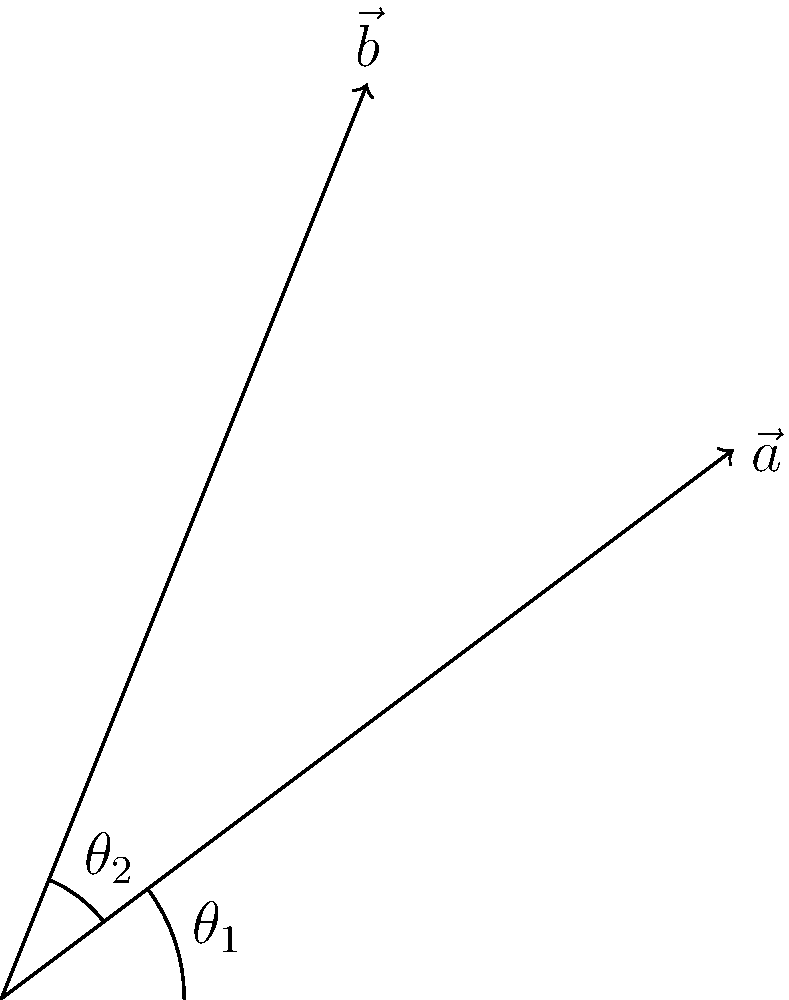Louise Hazel, a renowned heptathlete, is analyzing two shot put throws. The first throw is represented by vector $\vec{a} = 4\hat{i} + 3\hat{j}$, and the second throw by vector $\vec{b} = 2\hat{i} + 5\hat{j}$. What is the angle between these two vectors? To find the angle between two vectors, we can use the dot product formula:

$$\cos \theta = \frac{\vec{a} \cdot \vec{b}}{|\vec{a}||\vec{b}|}$$

Step 1: Calculate the dot product $\vec{a} \cdot \vec{b}$
$\vec{a} \cdot \vec{b} = (4)(2) + (3)(5) = 8 + 15 = 23$

Step 2: Calculate the magnitudes of $\vec{a}$ and $\vec{b}$
$|\vec{a}| = \sqrt{4^2 + 3^2} = \sqrt{16 + 9} = \sqrt{25} = 5$
$|\vec{b}| = \sqrt{2^2 + 5^2} = \sqrt{4 + 25} = \sqrt{29}$

Step 3: Apply the dot product formula
$$\cos \theta = \frac{23}{5\sqrt{29}}$$

Step 4: Take the inverse cosine (arccos) of both sides
$$\theta = \arccos\left(\frac{23}{5\sqrt{29}}\right)$$

Step 5: Calculate the result (approximately)
$\theta \approx 0.3398$ radians

Step 6: Convert to degrees
$\theta \approx 0.3398 \cdot \frac{180}{\pi} \approx 19.47°$
Answer: $19.47°$ 